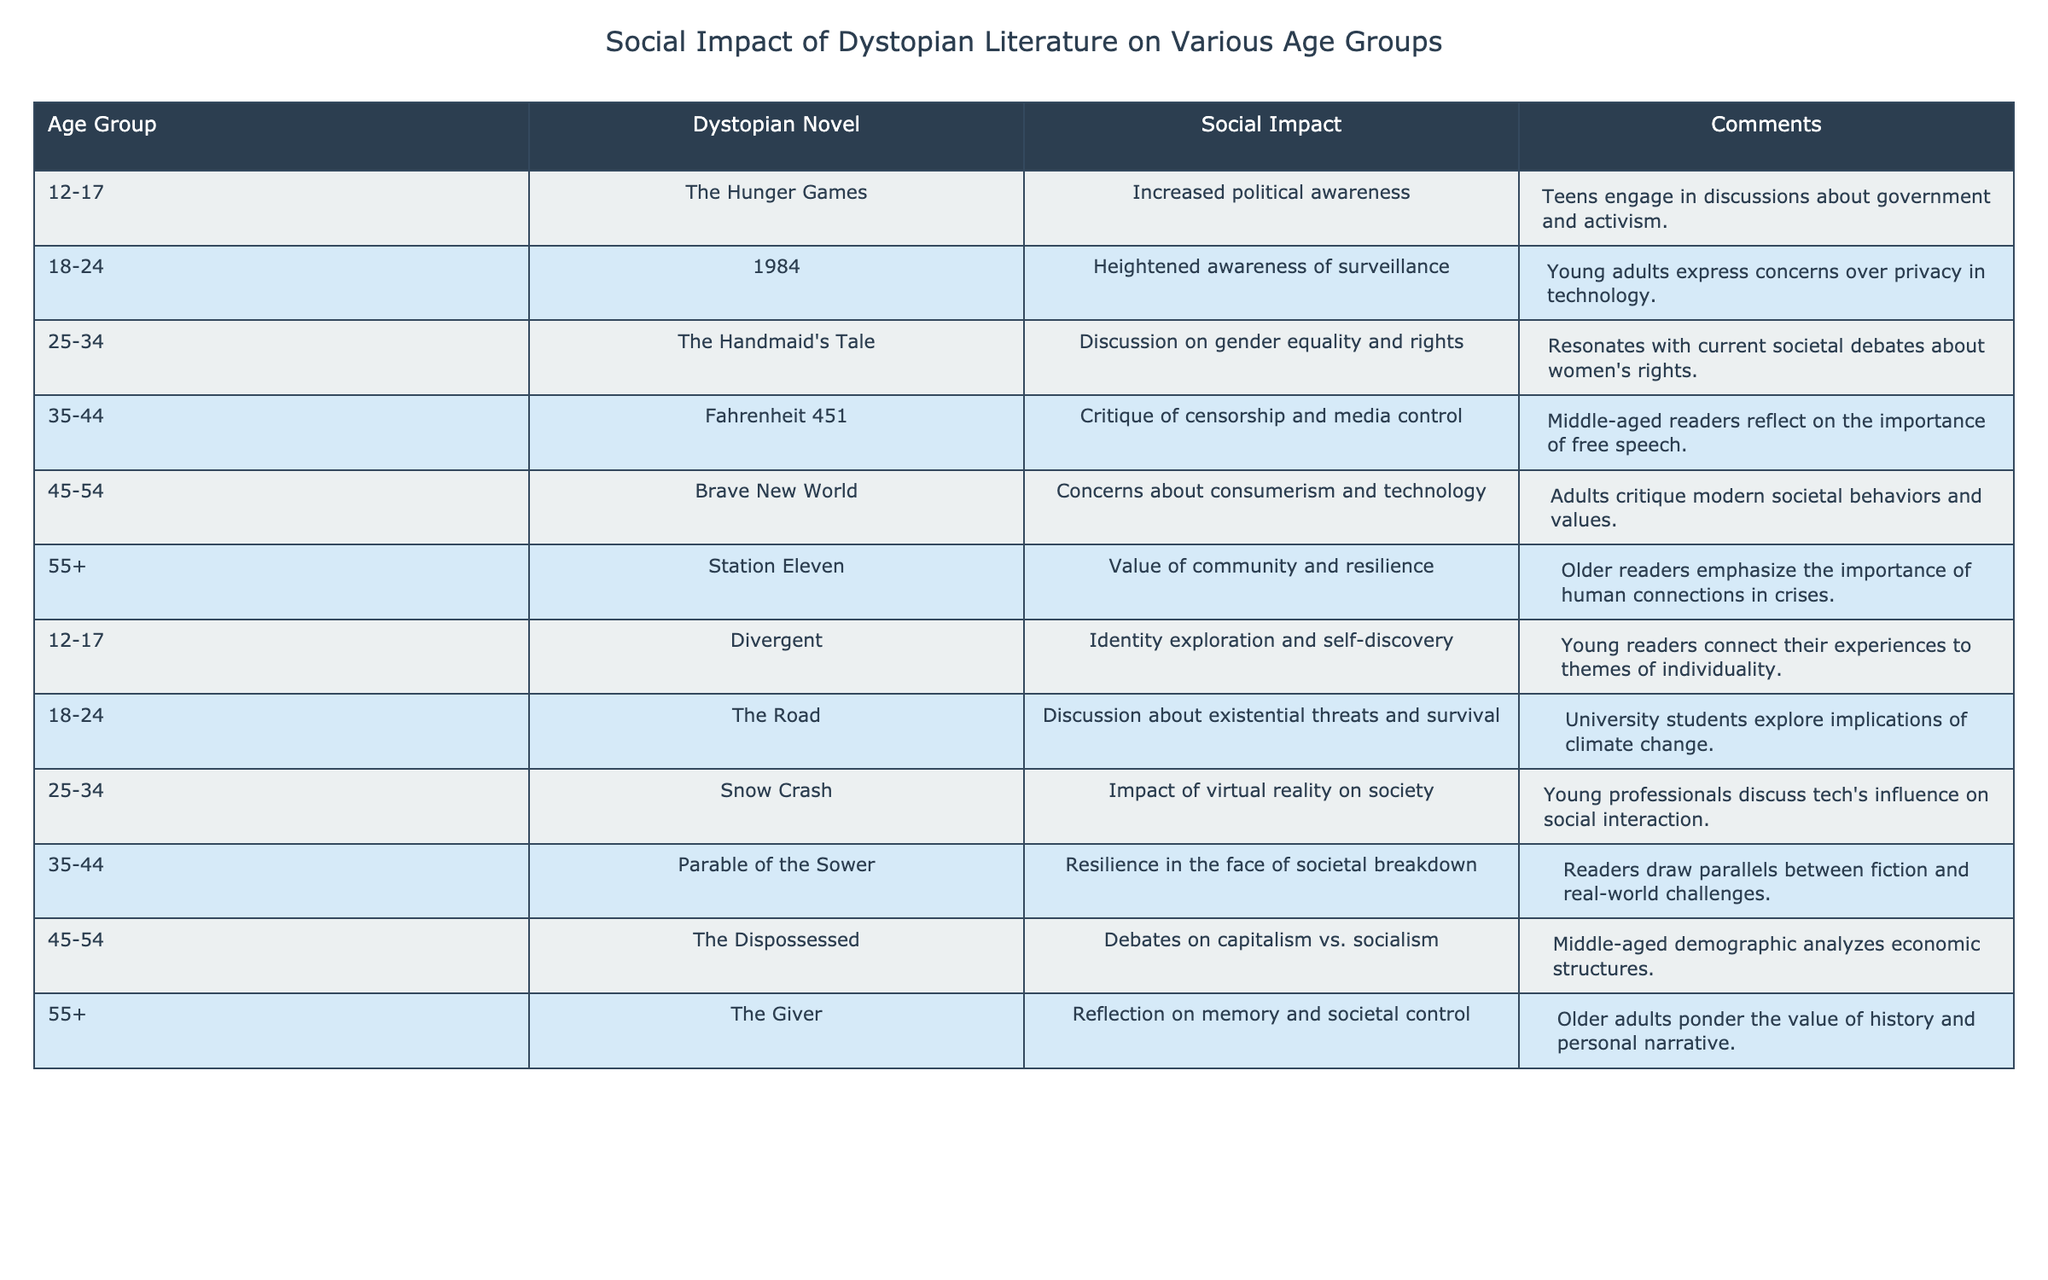What social impact is associated with "The Handmaid's Tale" for the age group 25-34? According to the table, "The Handmaid's Tale" is associated with a discussion on gender equality and rights among the age group 25-34.
Answer: Discussion on gender equality and rights Which age group connects themes of individuality with "Divergent"? The table indicates that the age group 12-17 relates themes of identity exploration and self-discovery to "Divergent."
Answer: 12-17 What concerns does "Fahrenheit 451" raise for the 35-44 age group? The social impact associated with "Fahrenheit 451" for the 35-44 age group is a critique of censorship and media control.
Answer: Critique of censorship and media control Which dystopian novel addresses issues of consumerism and technology for the 45-54 age group? The table shows that "Brave New World" raises concerns about consumerism and technology for the 45-54 age group.
Answer: Brave New World Is the social impact of "1984" related to privacy for young adults? Yes, the table specifies that "1984" heightens awareness of surveillance, which relates to privacy concerns for young adults.
Answer: Yes Among the novels listed, which emphasizes community and resilience for those aged 55 and older? The table lists "Station Eleven" as emphasizing the value of community and resilience for the 55+ age group.
Answer: Station Eleven What is the difference in social impact topics between the 12-17 and 45-54 age groups? The 12-17 age group discusses political awareness and identity exploration, while the 45-54 age group focuses on consumerism and technology. The difference lies in the thematic focus on youth activism versus critiques of modern societal behaviors.
Answer: Themes of political awareness and consumerism How many age groups express concerns about societal breakdown through dystopian literature? Analyzing the table, the age groups 35-44 (with "Parable of the Sower") and 18-24 (with "The Road") express concerns about societal breakdown. Thus, there are two age groups.
Answer: Two age groups What does the age group 55+ reflect on regarding "The Giver"? The social impact noted for the 55+ age group in relation to "The Giver" is a reflection on memory and societal control.
Answer: Reflection on memory and societal control Are there any novels that focus on gender-related themes in the 25-34 age group? Yes, the table notes that "The Handmaid's Tale" focuses on gender equality and rights for the 25-34 age group.
Answer: Yes 